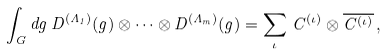Convert formula to latex. <formula><loc_0><loc_0><loc_500><loc_500>\int _ { G } d g \, D ^ { ( \Lambda _ { 1 } ) } ( g ) \otimes \cdots \otimes D ^ { ( \Lambda _ { m } ) } ( g ) = \sum _ { \iota } \, C ^ { ( \iota ) } \otimes \overline { C ^ { ( \iota ) } } \, ,</formula> 